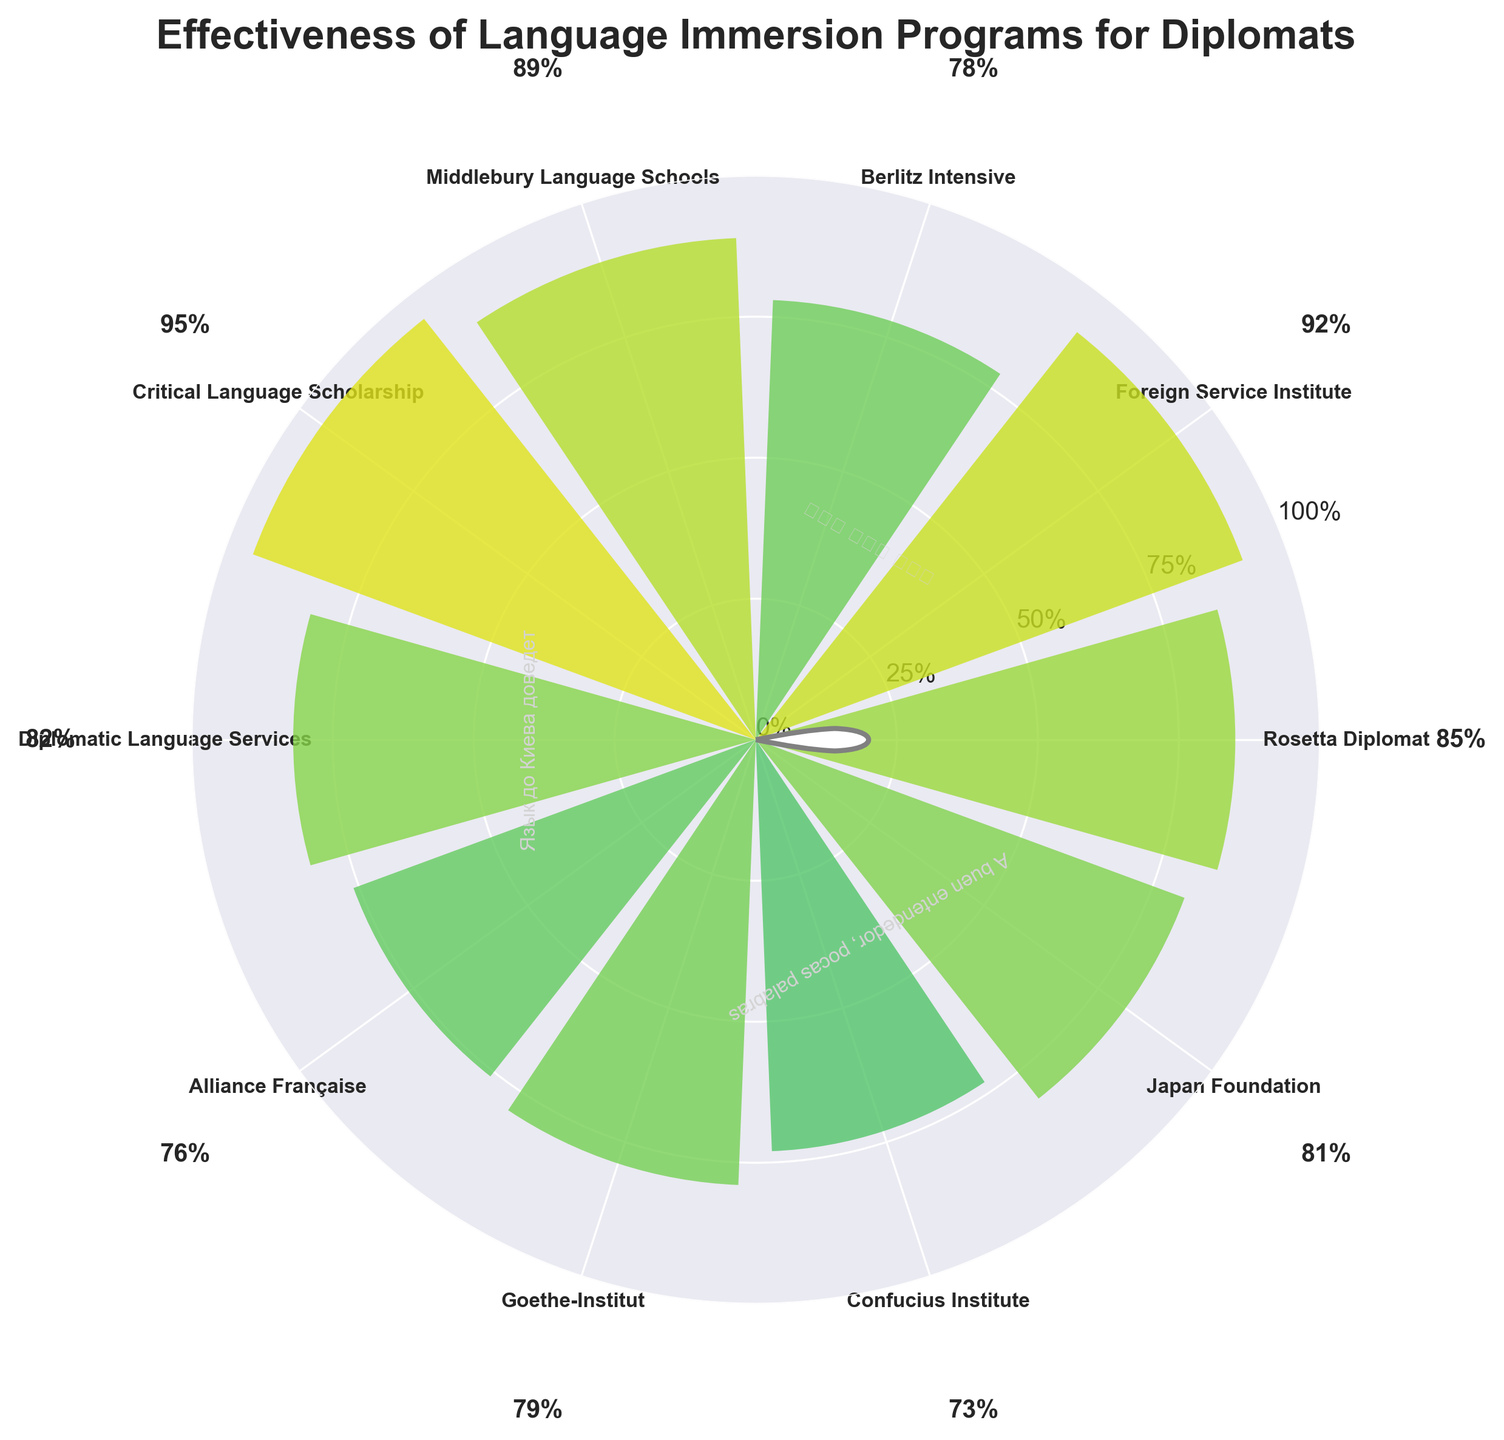Which program has the highest effectiveness rating? The highest effectiveness rating on the gauge chart is visually displayed with the largest radial value (closest to the outer edge). The "Critical Language Scholarship" program has the highest rating of 95%.
Answer: Critical Language Scholarship Which program has the lowest effectiveness rating? The lowest effectiveness rating is shown by the shortest radial value (closest to the center). The "Confucius Institute" program has the lowest rating at 73%.
Answer: Confucius Institute What is the title of this chart? The title of the chart is displayed at the top of the figure. It reads "Effectiveness of Language Immersion Programs for Diplomats."
Answer: Effectiveness of Language Immersion Programs for Diplomats How many programs have an effectiveness rating greater than 80%? To find this, count the number of radial bars extending beyond the 80% mark (shown by the 0.8 line on the radial plot). The programs are: Rosetta Diplomat, Foreign Service Institute, Middlebury Language Schools, Critical Language Scholarship, Diplomatic Language Services, and Japan Foundation. This totals six programs.
Answer: Six Which programs have a higher effectiveness rating than Berlitz Intensive? Find the Berlitz Intensive effectiveness rating, which is 78%. Then identify the programs with bars that extend further out than this radial value: Rosetta Diplomat, Foreign Service Institute, Middlebury Language Schools, Critical Language Scholarship, Diplomatic Language Services, Japan Foundation.
Answer: Rosetta Diplomat, Foreign Service Institute, Middlebury Language Schools, Critical Language Scholarship, Diplomatic Language Services, Japan Foundation Determine the average effectiveness rating of all the programs. Sum all the effectiveness ratings and divide by the total number of programs. Ratings are 85, 92, 78, 89, 95, 82, 76, 79, 73, and 81. The sum is 830. Divide 830 by 10 (number of programs) to get an average of 83%.
Answer: 83% What is the difference in effectiveness between the Foreign Service Institute and Alliance Française? Subtract the effectiveness of Alliance Française (76%) from the Foreign Service Institute (92%). The difference is 92 - 76 = 16%.
Answer: 16% Which program is rated just above Berlitz Intensive? Berlitz Intensive is rated at 78%. The next program with a slightly higher rating is Goethe-Institut with a rating of 79%.
Answer: Goethe-Institut Are there any idioms included in the chart? If so, state one. The chart includes several idioms in different languages as easter eggs, visible around the central circle. One example is "언어의 바다에 빠지다" which translates roughly to "plunging into a sea of language" in Korean.
Answer: 언어의 바다에 빠지다 